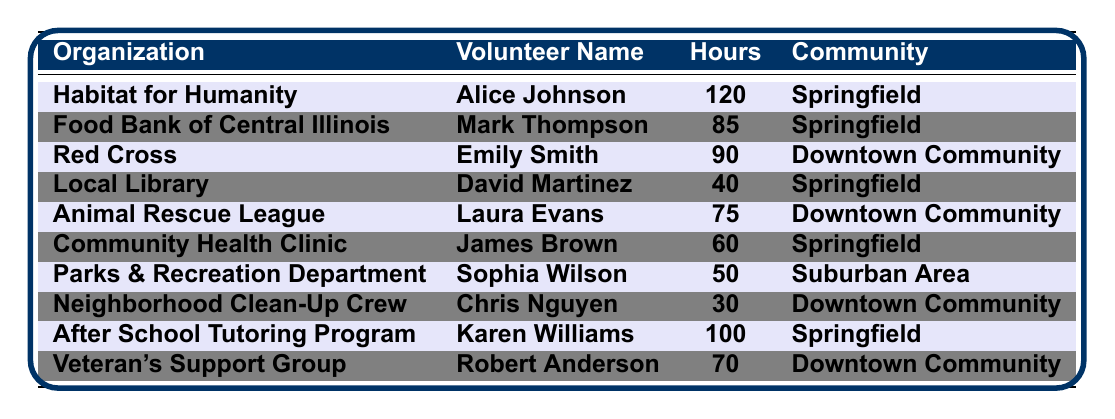What is the maximum number of volunteer hours contributed by an individual in Springfield? The table shows that Alice Johnson contributed the maximum hours (120) in Springfield.
Answer: 120 What is the total number of volunteer hours contributed by residents of Downtown Community? Adding the hours for Downtown Community members: 90 (Emily Smith) + 75 (Laura Evans) + 30 (Chris Nguyen) + 70 (Robert Anderson) = 265 hours.
Answer: 265 Which organization received the least amount of volunteer hours from Springfield community members? The Local Library received 40 hours, which is the least among organizations based in Springfield.
Answer: Local Library Did anyone contribute volunteer hours to the Parks & Recreation Department? The table provides information that Sophia Wilson contributed 50 hours to the Parks & Recreation Department.
Answer: Yes What is the average number of volunteer hours contributed by members of Springfield? The total hours for Springfield residents is 120 + 85 + 40 + 60 + 100 = 405 hours. There are 5 volunteers, so the average is 405/5 = 81.
Answer: 81 Which volunteer contributed the most hours overall and to which organization? Alice Johnson contributed the most hours (120) to Habitat for Humanity.
Answer: Alice Johnson, Habitat for Humanity Are there more volunteers who contributed under 50 hours or over 50 hours in total? Volunteers with under 50 hours: Chris Nguyen (30) and David Martinez (40), totaling 70 hours. Volunteers over 50 hours: Alice Johnson (120), Mark Thompson (85), Emily Smith (90), Laura Evans (75), James Brown (60), Sophia Wilson (50), and Robert Anderson (70), totaling 520 hours.
Answer: More over 50 hours How many volunteers contributed to the Food Bank of Central Illinois? Only one volunteer, Mark Thompson, contributed to the Food Bank of Central Illinois.
Answer: 1 What percentage of the total volunteer hours came from the organization with the most contributions? The total hours contributed by all volunteers is 555 (sum of all hours). Alice Johnson's hours (120) constitute (120/555)*100 = approximately 21.62%.
Answer: 21.62% What is the difference in volunteer hours contributed between the highest and lowest contributors in the Downtown Community? The highest contributor in Downtown Community is Emily Smith with 90 hours, the lowest is Chris Nguyen with 30 hours. The difference is 90 - 30 = 60 hours.
Answer: 60 